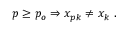Convert formula to latex. <formula><loc_0><loc_0><loc_500><loc_500>p \geq p _ { o } \Rightarrow x _ { p k } \ne x _ { k } \ .</formula> 